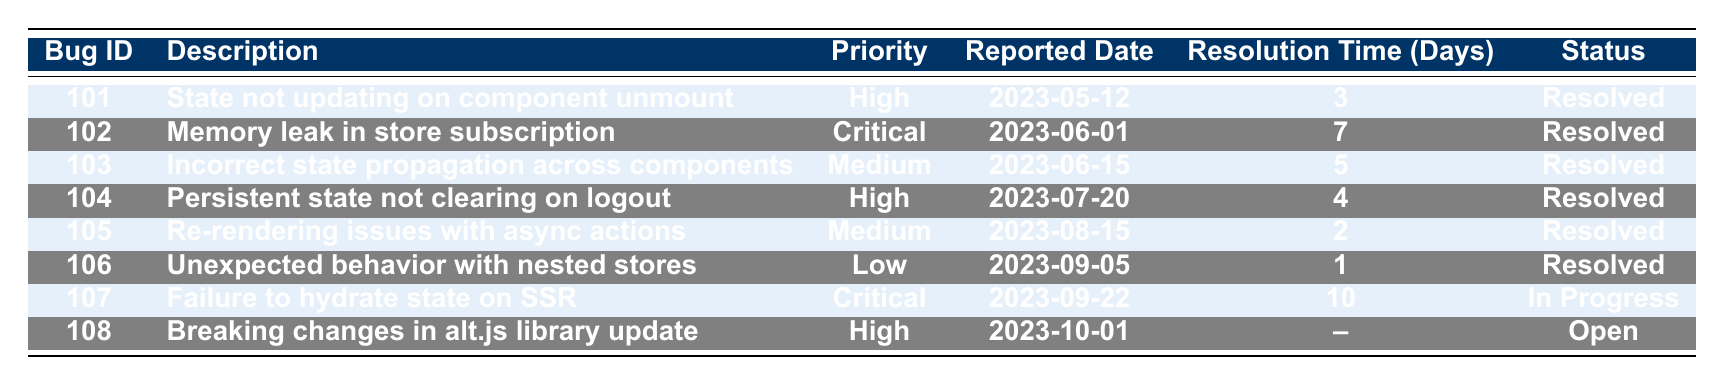What is the resolution time for the bug reported by Alice Johnson? Referring to the table, Alice Johnson reported a bug with ID 101, and the resolution time for that bug is 3 days.
Answer: 3 days Which bug has the longest resolution time? Looking through the table, bug ID 107 has a resolution time of 10 days, which is the longest compared to other entries.
Answer: Bug ID 107 How many bugs reported were marked as 'Resolved'? By counting the status column, all except for bug ID 107 and 108 are marked as 'Resolved', which totals to 6 bugs.
Answer: 6 What is the priority level of bug ID 102? Checking the row for bug ID 102 shows that its priority level is marked as Critical.
Answer: Critical How many bugs have a resolution time of less than 4 days? In the table, the bugs with ID 105 and 106 have resolution times of 2 and 1 day, respectively, which makes a total of 2 bugs with resolution times less than 4 days.
Answer: 2 Is there a bug reported by Michael Scott that is still open? Looking at the row with Michael Scott's report (bug ID 107), the status is 'In Progress', not 'Open', and thus, there is no bug he reported that is open.
Answer: No What is the average resolution time for all resolved bugs? Add the resolution days for resolved bugs only: (3 + 7 + 5 + 4 + 2 + 1) = 22 days. There are 6 resolved bugs, hence the average resolution time is 22/6 ≈ 3.67 days.
Answer: Approximately 3.67 days Which bug reported on 2023-10-01 is still open? Referring to the table, the bug reported on 2023-10-01 is bug ID 108, and its status is marked as Open.
Answer: Bug ID 108 Did any bug report exceed a resolution time of 5 days? Yes, bug ID 102 has a resolution time of 7 days, which exceeds 5 days.
Answer: Yes Which reporter has the highest priority bug listed? Looking at the table, the highest priority listed is Critical for bug ID 102 reported by Charlie Brown.
Answer: Charlie Brown 